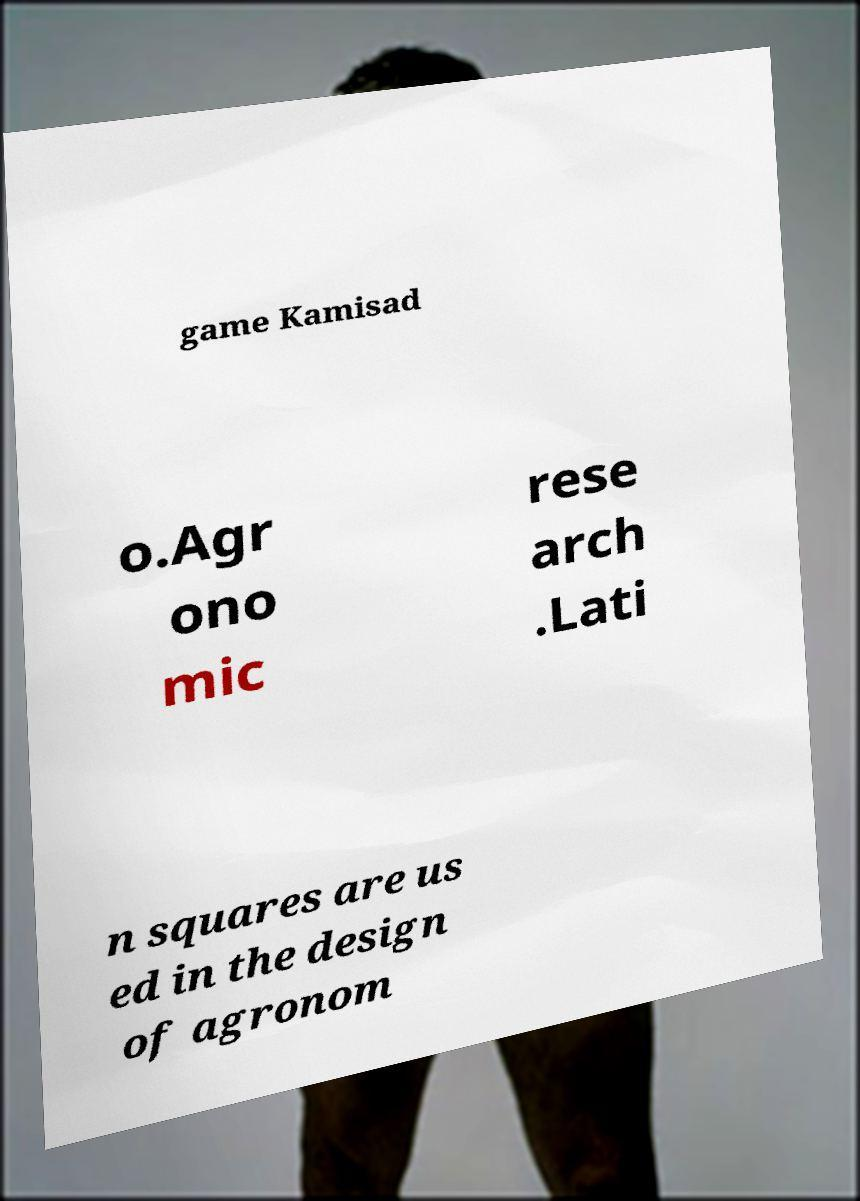What messages or text are displayed in this image? I need them in a readable, typed format. game Kamisad o.Agr ono mic rese arch .Lati n squares are us ed in the design of agronom 